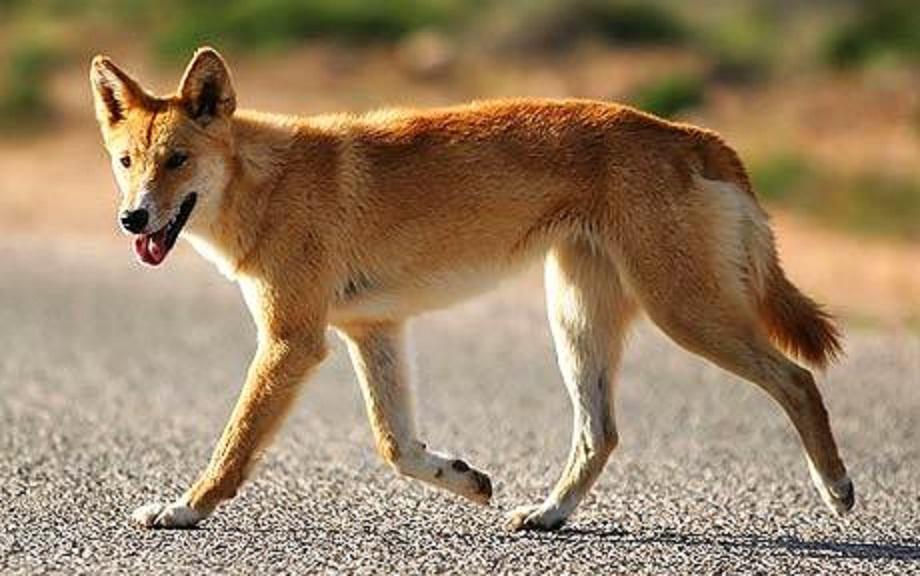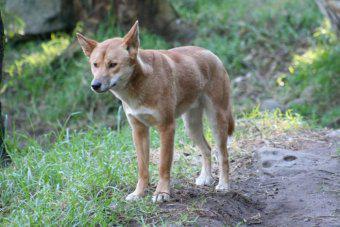The first image is the image on the left, the second image is the image on the right. Evaluate the accuracy of this statement regarding the images: "There are no more than 2 dogs per image pair". Is it true? Answer yes or no. Yes. The first image is the image on the left, the second image is the image on the right. Assess this claim about the two images: "In at least one image, there are no less than two yellow and white canines standing.". Correct or not? Answer yes or no. No. 